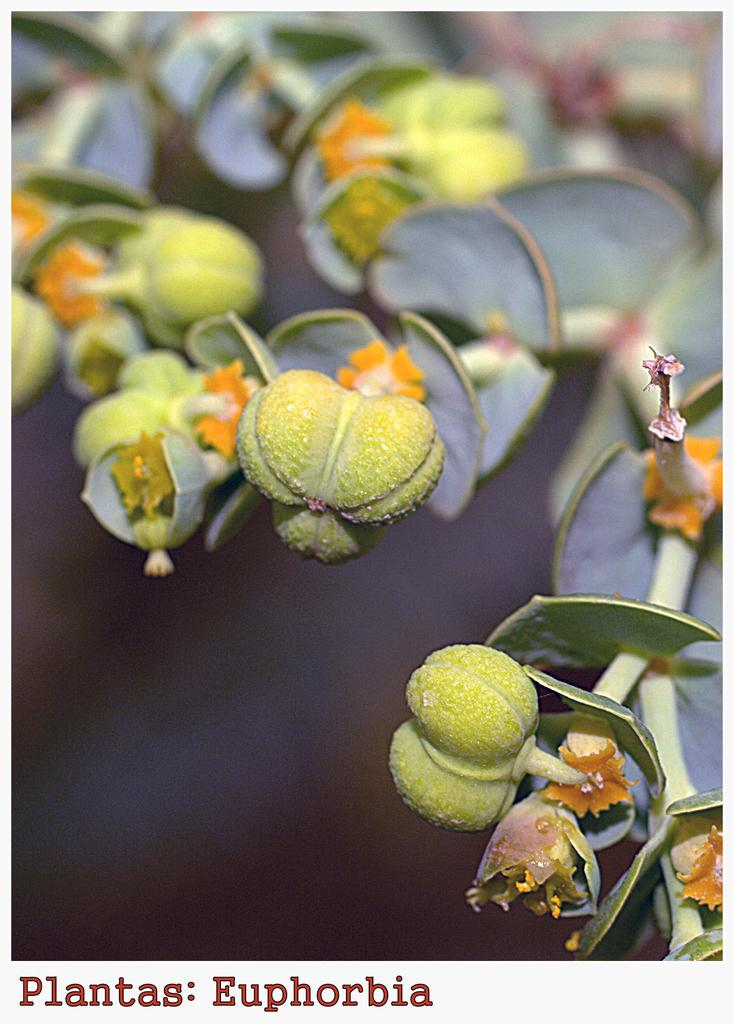What type of plants can be seen in the image? There are flowers in the image. How are the flowers attached to the stems? The flowers are on stems. What type of current is flowing through the flowers in the image? There is no current present in the image; it features flowers on stems. How does the bun relate to the flowers in the image? There is no bun present in the image; it features flowers on stems. 